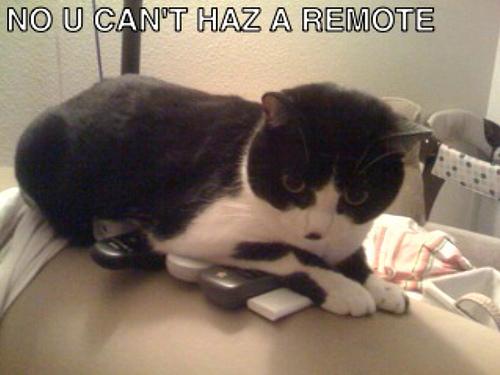What color is the tip of the cat's nose?
Give a very brief answer. Black. What is the cat doing?
Concise answer only. Staring. What is the cat sitting on?
Quick response, please. Remotes. 